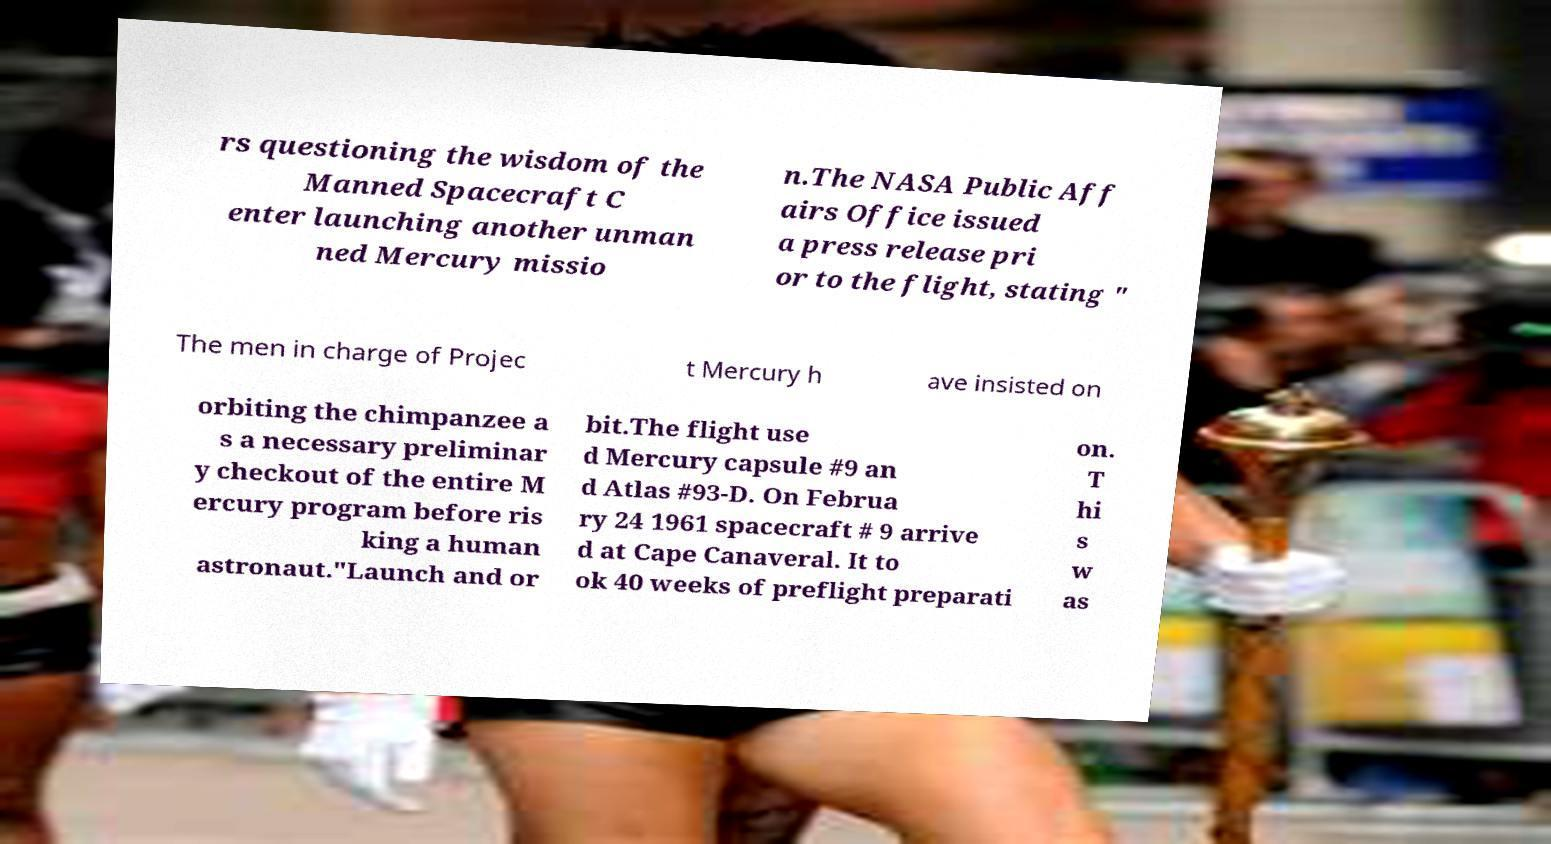Please identify and transcribe the text found in this image. rs questioning the wisdom of the Manned Spacecraft C enter launching another unman ned Mercury missio n.The NASA Public Aff airs Office issued a press release pri or to the flight, stating " The men in charge of Projec t Mercury h ave insisted on orbiting the chimpanzee a s a necessary preliminar y checkout of the entire M ercury program before ris king a human astronaut."Launch and or bit.The flight use d Mercury capsule #9 an d Atlas #93-D. On Februa ry 24 1961 spacecraft # 9 arrive d at Cape Canaveral. It to ok 40 weeks of preflight preparati on. T hi s w as 